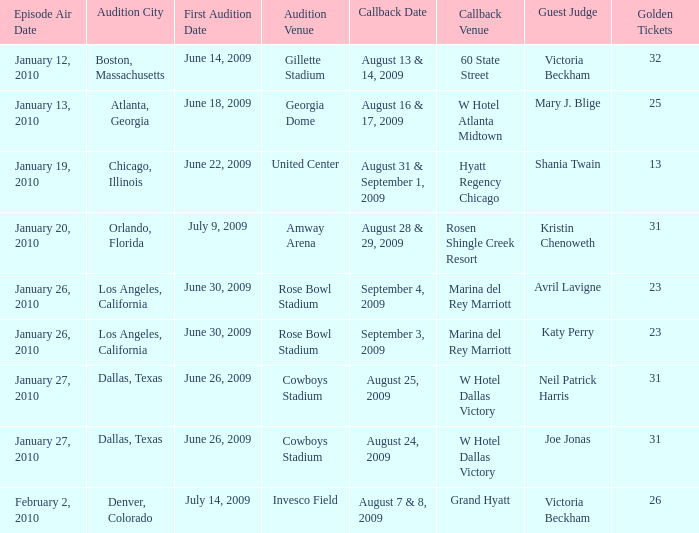Identify the callback date for amway arena. August 28 & 29, 2009. 